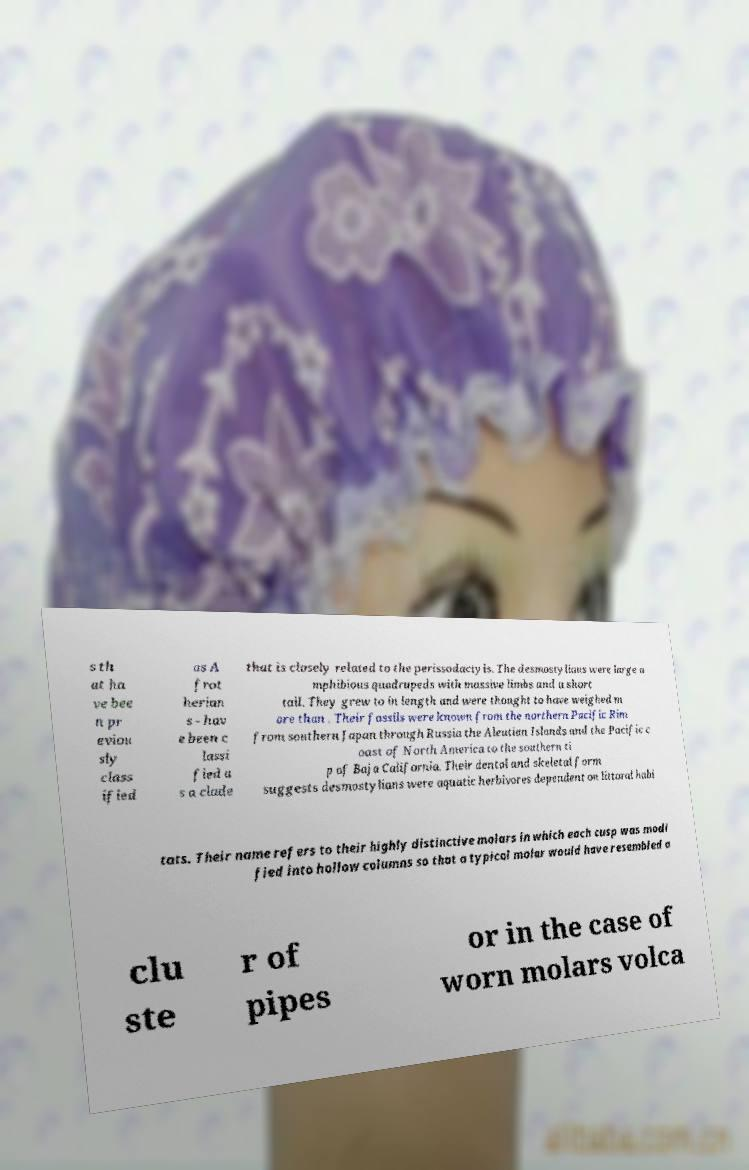Could you extract and type out the text from this image? s th at ha ve bee n pr eviou sly class ified as A frot herian s - hav e been c lassi fied a s a clade that is closely related to the perissodactyls. The desmostylians were large a mphibious quadrupeds with massive limbs and a short tail. They grew to in length and were thought to have weighed m ore than . Their fossils were known from the northern Pacific Rim from southern Japan through Russia the Aleutian Islands and the Pacific c oast of North America to the southern ti p of Baja California. Their dental and skeletal form suggests desmostylians were aquatic herbivores dependent on littoral habi tats. Their name refers to their highly distinctive molars in which each cusp was modi fied into hollow columns so that a typical molar would have resembled a clu ste r of pipes or in the case of worn molars volca 